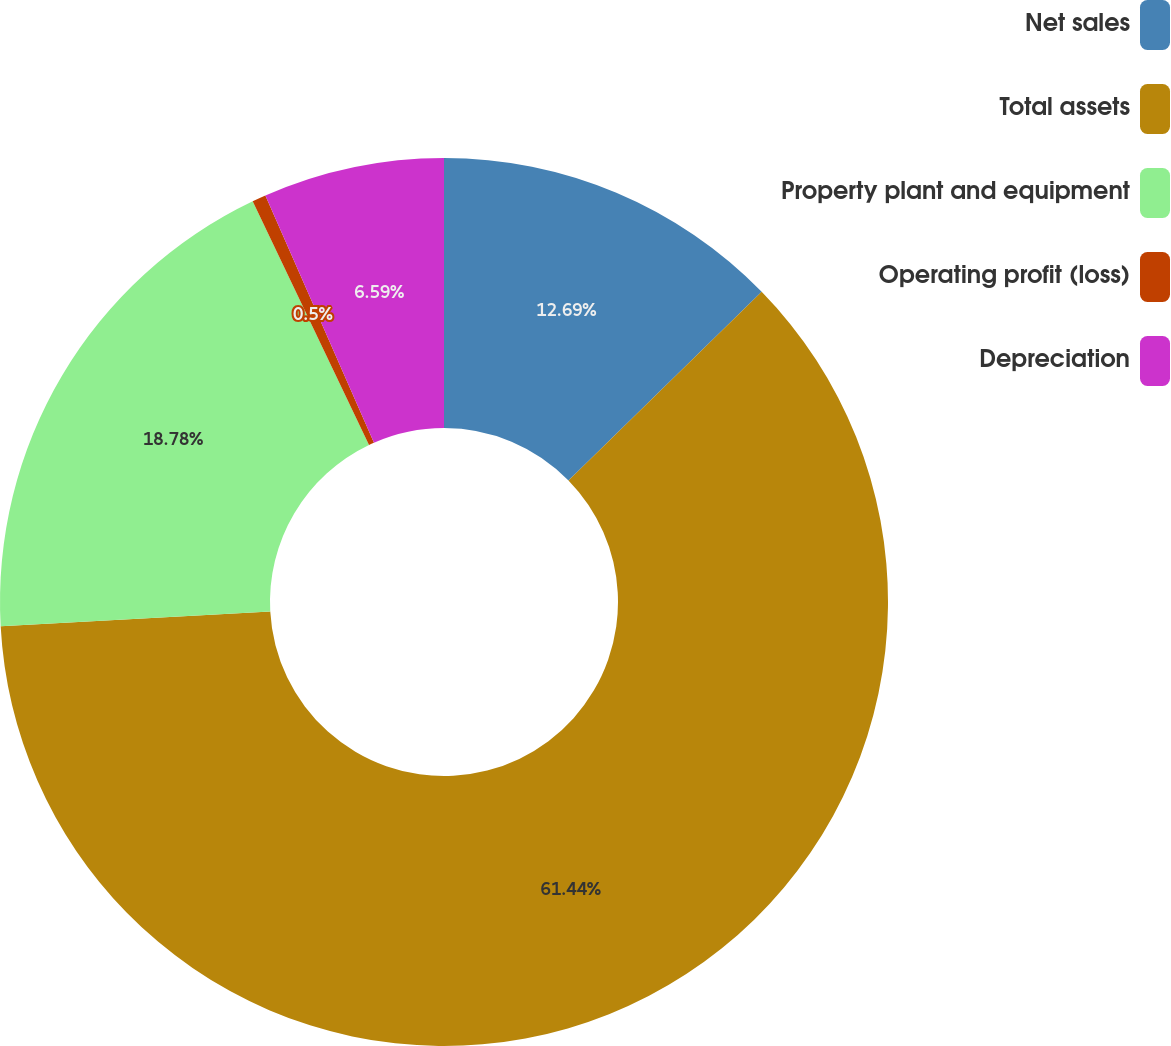<chart> <loc_0><loc_0><loc_500><loc_500><pie_chart><fcel>Net sales<fcel>Total assets<fcel>Property plant and equipment<fcel>Operating profit (loss)<fcel>Depreciation<nl><fcel>12.69%<fcel>61.44%<fcel>18.78%<fcel>0.5%<fcel>6.59%<nl></chart> 